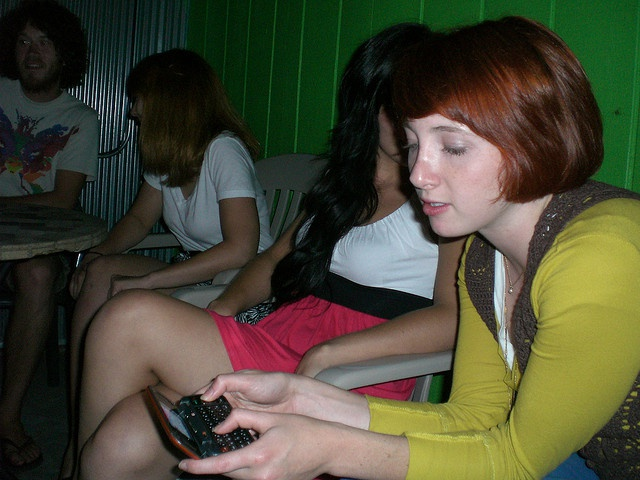Describe the objects in this image and their specific colors. I can see people in black, olive, and darkgray tones, people in black, gray, and maroon tones, people in black and gray tones, people in black and purple tones, and dining table in black and gray tones in this image. 